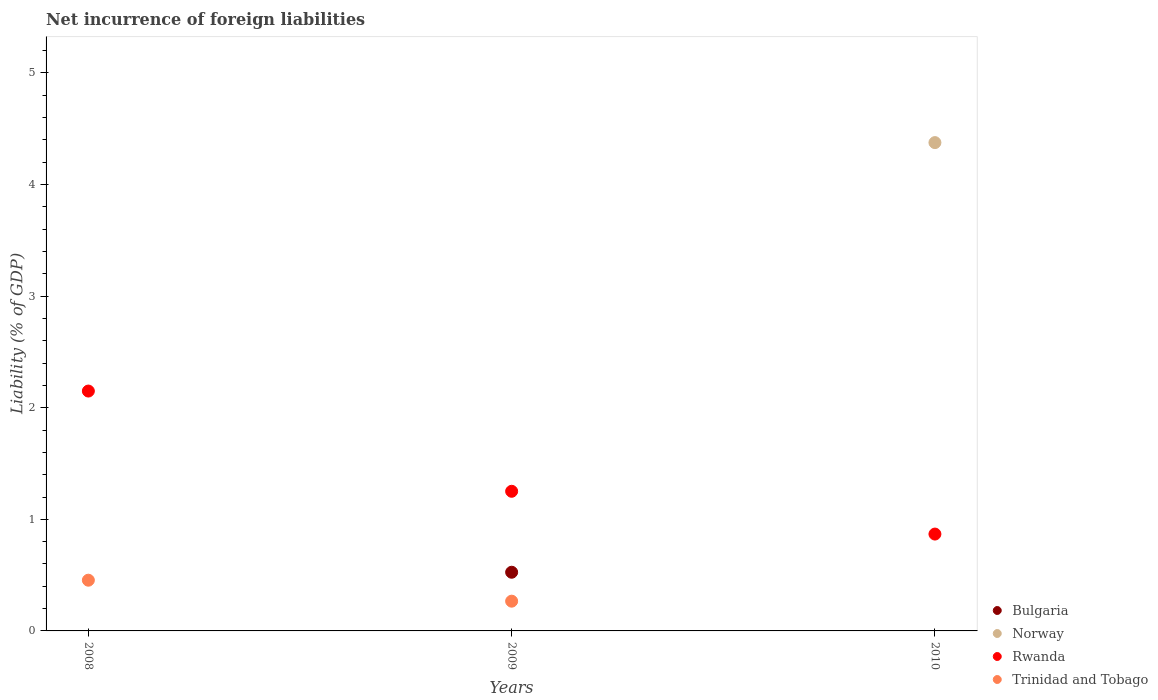What is the net incurrence of foreign liabilities in Norway in 2010?
Your response must be concise. 4.38. Across all years, what is the maximum net incurrence of foreign liabilities in Trinidad and Tobago?
Your answer should be compact. 0.45. Across all years, what is the minimum net incurrence of foreign liabilities in Trinidad and Tobago?
Provide a succinct answer. 0. In which year was the net incurrence of foreign liabilities in Trinidad and Tobago maximum?
Ensure brevity in your answer.  2008. What is the total net incurrence of foreign liabilities in Bulgaria in the graph?
Offer a terse response. 0.53. What is the difference between the net incurrence of foreign liabilities in Rwanda in 2009 and that in 2010?
Your answer should be compact. 0.38. What is the difference between the net incurrence of foreign liabilities in Norway in 2009 and the net incurrence of foreign liabilities in Trinidad and Tobago in 2008?
Your response must be concise. -0.45. What is the average net incurrence of foreign liabilities in Bulgaria per year?
Give a very brief answer. 0.18. In the year 2009, what is the difference between the net incurrence of foreign liabilities in Bulgaria and net incurrence of foreign liabilities in Rwanda?
Provide a succinct answer. -0.73. What is the ratio of the net incurrence of foreign liabilities in Trinidad and Tobago in 2008 to that in 2009?
Offer a very short reply. 1.71. Is the net incurrence of foreign liabilities in Rwanda in 2008 less than that in 2009?
Your answer should be very brief. No. What is the difference between the highest and the second highest net incurrence of foreign liabilities in Rwanda?
Provide a succinct answer. 0.9. What is the difference between the highest and the lowest net incurrence of foreign liabilities in Rwanda?
Keep it short and to the point. 1.28. Is the sum of the net incurrence of foreign liabilities in Rwanda in 2008 and 2009 greater than the maximum net incurrence of foreign liabilities in Trinidad and Tobago across all years?
Make the answer very short. Yes. Is it the case that in every year, the sum of the net incurrence of foreign liabilities in Norway and net incurrence of foreign liabilities in Rwanda  is greater than the net incurrence of foreign liabilities in Trinidad and Tobago?
Make the answer very short. Yes. Does the net incurrence of foreign liabilities in Norway monotonically increase over the years?
Offer a terse response. No. Is the net incurrence of foreign liabilities in Trinidad and Tobago strictly greater than the net incurrence of foreign liabilities in Rwanda over the years?
Offer a very short reply. No. What is the difference between two consecutive major ticks on the Y-axis?
Provide a succinct answer. 1. Are the values on the major ticks of Y-axis written in scientific E-notation?
Your answer should be compact. No. How many legend labels are there?
Offer a terse response. 4. How are the legend labels stacked?
Your answer should be very brief. Vertical. What is the title of the graph?
Your response must be concise. Net incurrence of foreign liabilities. Does "Italy" appear as one of the legend labels in the graph?
Provide a short and direct response. No. What is the label or title of the Y-axis?
Offer a terse response. Liability (% of GDP). What is the Liability (% of GDP) of Bulgaria in 2008?
Ensure brevity in your answer.  0. What is the Liability (% of GDP) of Rwanda in 2008?
Ensure brevity in your answer.  2.15. What is the Liability (% of GDP) in Trinidad and Tobago in 2008?
Your answer should be compact. 0.45. What is the Liability (% of GDP) in Bulgaria in 2009?
Make the answer very short. 0.53. What is the Liability (% of GDP) in Rwanda in 2009?
Your answer should be compact. 1.25. What is the Liability (% of GDP) in Trinidad and Tobago in 2009?
Provide a succinct answer. 0.27. What is the Liability (% of GDP) of Bulgaria in 2010?
Ensure brevity in your answer.  0. What is the Liability (% of GDP) of Norway in 2010?
Your response must be concise. 4.38. What is the Liability (% of GDP) of Rwanda in 2010?
Your response must be concise. 0.87. Across all years, what is the maximum Liability (% of GDP) of Bulgaria?
Your response must be concise. 0.53. Across all years, what is the maximum Liability (% of GDP) in Norway?
Your response must be concise. 4.38. Across all years, what is the maximum Liability (% of GDP) of Rwanda?
Offer a terse response. 2.15. Across all years, what is the maximum Liability (% of GDP) of Trinidad and Tobago?
Provide a succinct answer. 0.45. Across all years, what is the minimum Liability (% of GDP) in Norway?
Offer a terse response. 0. Across all years, what is the minimum Liability (% of GDP) in Rwanda?
Offer a very short reply. 0.87. What is the total Liability (% of GDP) of Bulgaria in the graph?
Make the answer very short. 0.53. What is the total Liability (% of GDP) in Norway in the graph?
Ensure brevity in your answer.  4.38. What is the total Liability (% of GDP) of Rwanda in the graph?
Keep it short and to the point. 4.27. What is the total Liability (% of GDP) in Trinidad and Tobago in the graph?
Provide a short and direct response. 0.72. What is the difference between the Liability (% of GDP) in Rwanda in 2008 and that in 2009?
Give a very brief answer. 0.9. What is the difference between the Liability (% of GDP) in Trinidad and Tobago in 2008 and that in 2009?
Keep it short and to the point. 0.19. What is the difference between the Liability (% of GDP) of Rwanda in 2008 and that in 2010?
Make the answer very short. 1.28. What is the difference between the Liability (% of GDP) of Rwanda in 2009 and that in 2010?
Provide a short and direct response. 0.38. What is the difference between the Liability (% of GDP) of Rwanda in 2008 and the Liability (% of GDP) of Trinidad and Tobago in 2009?
Provide a succinct answer. 1.88. What is the difference between the Liability (% of GDP) of Bulgaria in 2009 and the Liability (% of GDP) of Norway in 2010?
Ensure brevity in your answer.  -3.85. What is the difference between the Liability (% of GDP) of Bulgaria in 2009 and the Liability (% of GDP) of Rwanda in 2010?
Provide a succinct answer. -0.34. What is the average Liability (% of GDP) in Bulgaria per year?
Make the answer very short. 0.18. What is the average Liability (% of GDP) in Norway per year?
Provide a short and direct response. 1.46. What is the average Liability (% of GDP) in Rwanda per year?
Give a very brief answer. 1.42. What is the average Liability (% of GDP) of Trinidad and Tobago per year?
Offer a terse response. 0.24. In the year 2008, what is the difference between the Liability (% of GDP) of Rwanda and Liability (% of GDP) of Trinidad and Tobago?
Offer a terse response. 1.7. In the year 2009, what is the difference between the Liability (% of GDP) in Bulgaria and Liability (% of GDP) in Rwanda?
Your answer should be very brief. -0.73. In the year 2009, what is the difference between the Liability (% of GDP) in Bulgaria and Liability (% of GDP) in Trinidad and Tobago?
Your answer should be very brief. 0.26. In the year 2009, what is the difference between the Liability (% of GDP) in Rwanda and Liability (% of GDP) in Trinidad and Tobago?
Make the answer very short. 0.98. In the year 2010, what is the difference between the Liability (% of GDP) of Norway and Liability (% of GDP) of Rwanda?
Offer a very short reply. 3.51. What is the ratio of the Liability (% of GDP) of Rwanda in 2008 to that in 2009?
Ensure brevity in your answer.  1.72. What is the ratio of the Liability (% of GDP) in Trinidad and Tobago in 2008 to that in 2009?
Give a very brief answer. 1.71. What is the ratio of the Liability (% of GDP) in Rwanda in 2008 to that in 2010?
Offer a very short reply. 2.48. What is the ratio of the Liability (% of GDP) of Rwanda in 2009 to that in 2010?
Offer a very short reply. 1.44. What is the difference between the highest and the second highest Liability (% of GDP) of Rwanda?
Your answer should be very brief. 0.9. What is the difference between the highest and the lowest Liability (% of GDP) of Bulgaria?
Ensure brevity in your answer.  0.53. What is the difference between the highest and the lowest Liability (% of GDP) in Norway?
Offer a terse response. 4.38. What is the difference between the highest and the lowest Liability (% of GDP) of Rwanda?
Offer a very short reply. 1.28. What is the difference between the highest and the lowest Liability (% of GDP) in Trinidad and Tobago?
Your answer should be very brief. 0.45. 